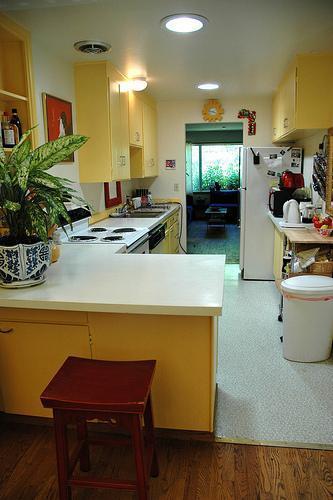How many stools?
Give a very brief answer. 1. 